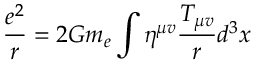<formula> <loc_0><loc_0><loc_500><loc_500>\frac { e ^ { 2 } } { r } = 2 G m _ { e } \int \eta ^ { \mu v } \frac { T _ { \mu v } } { r } d ^ { 3 } x</formula> 